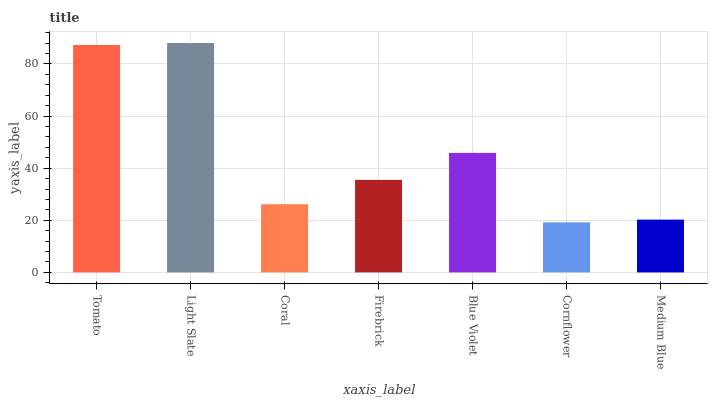Is Cornflower the minimum?
Answer yes or no. Yes. Is Light Slate the maximum?
Answer yes or no. Yes. Is Coral the minimum?
Answer yes or no. No. Is Coral the maximum?
Answer yes or no. No. Is Light Slate greater than Coral?
Answer yes or no. Yes. Is Coral less than Light Slate?
Answer yes or no. Yes. Is Coral greater than Light Slate?
Answer yes or no. No. Is Light Slate less than Coral?
Answer yes or no. No. Is Firebrick the high median?
Answer yes or no. Yes. Is Firebrick the low median?
Answer yes or no. Yes. Is Light Slate the high median?
Answer yes or no. No. Is Tomato the low median?
Answer yes or no. No. 